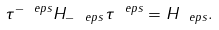Convert formula to latex. <formula><loc_0><loc_0><loc_500><loc_500>\tau ^ { - \ e p s } H _ { - \ e p s } \tau ^ { \ e p s } = H _ { \ e p s } .</formula> 